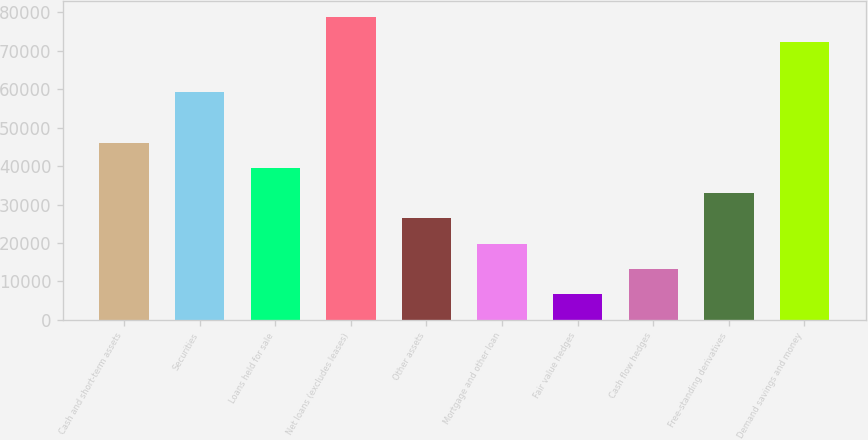Convert chart. <chart><loc_0><loc_0><loc_500><loc_500><bar_chart><fcel>Cash and short-term assets<fcel>Securities<fcel>Loans held for sale<fcel>Net loans (excludes leases)<fcel>Other assets<fcel>Mortgage and other loan<fcel>Fair value hedges<fcel>Cash flow hedges<fcel>Free-standing derivatives<fcel>Demand savings and money<nl><fcel>46104.3<fcel>59240.1<fcel>39536.4<fcel>78943.8<fcel>26400.6<fcel>19832.7<fcel>6696.9<fcel>13264.8<fcel>32968.5<fcel>72375.9<nl></chart> 